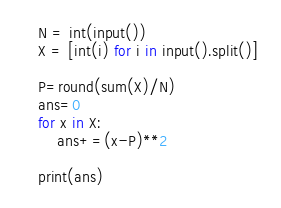Convert code to text. <code><loc_0><loc_0><loc_500><loc_500><_Python_>N = int(input())
X = [int(i) for i in input().split()]

P=round(sum(X)/N)
ans=0
for x in X:
    ans+=(x-P)**2

print(ans)</code> 